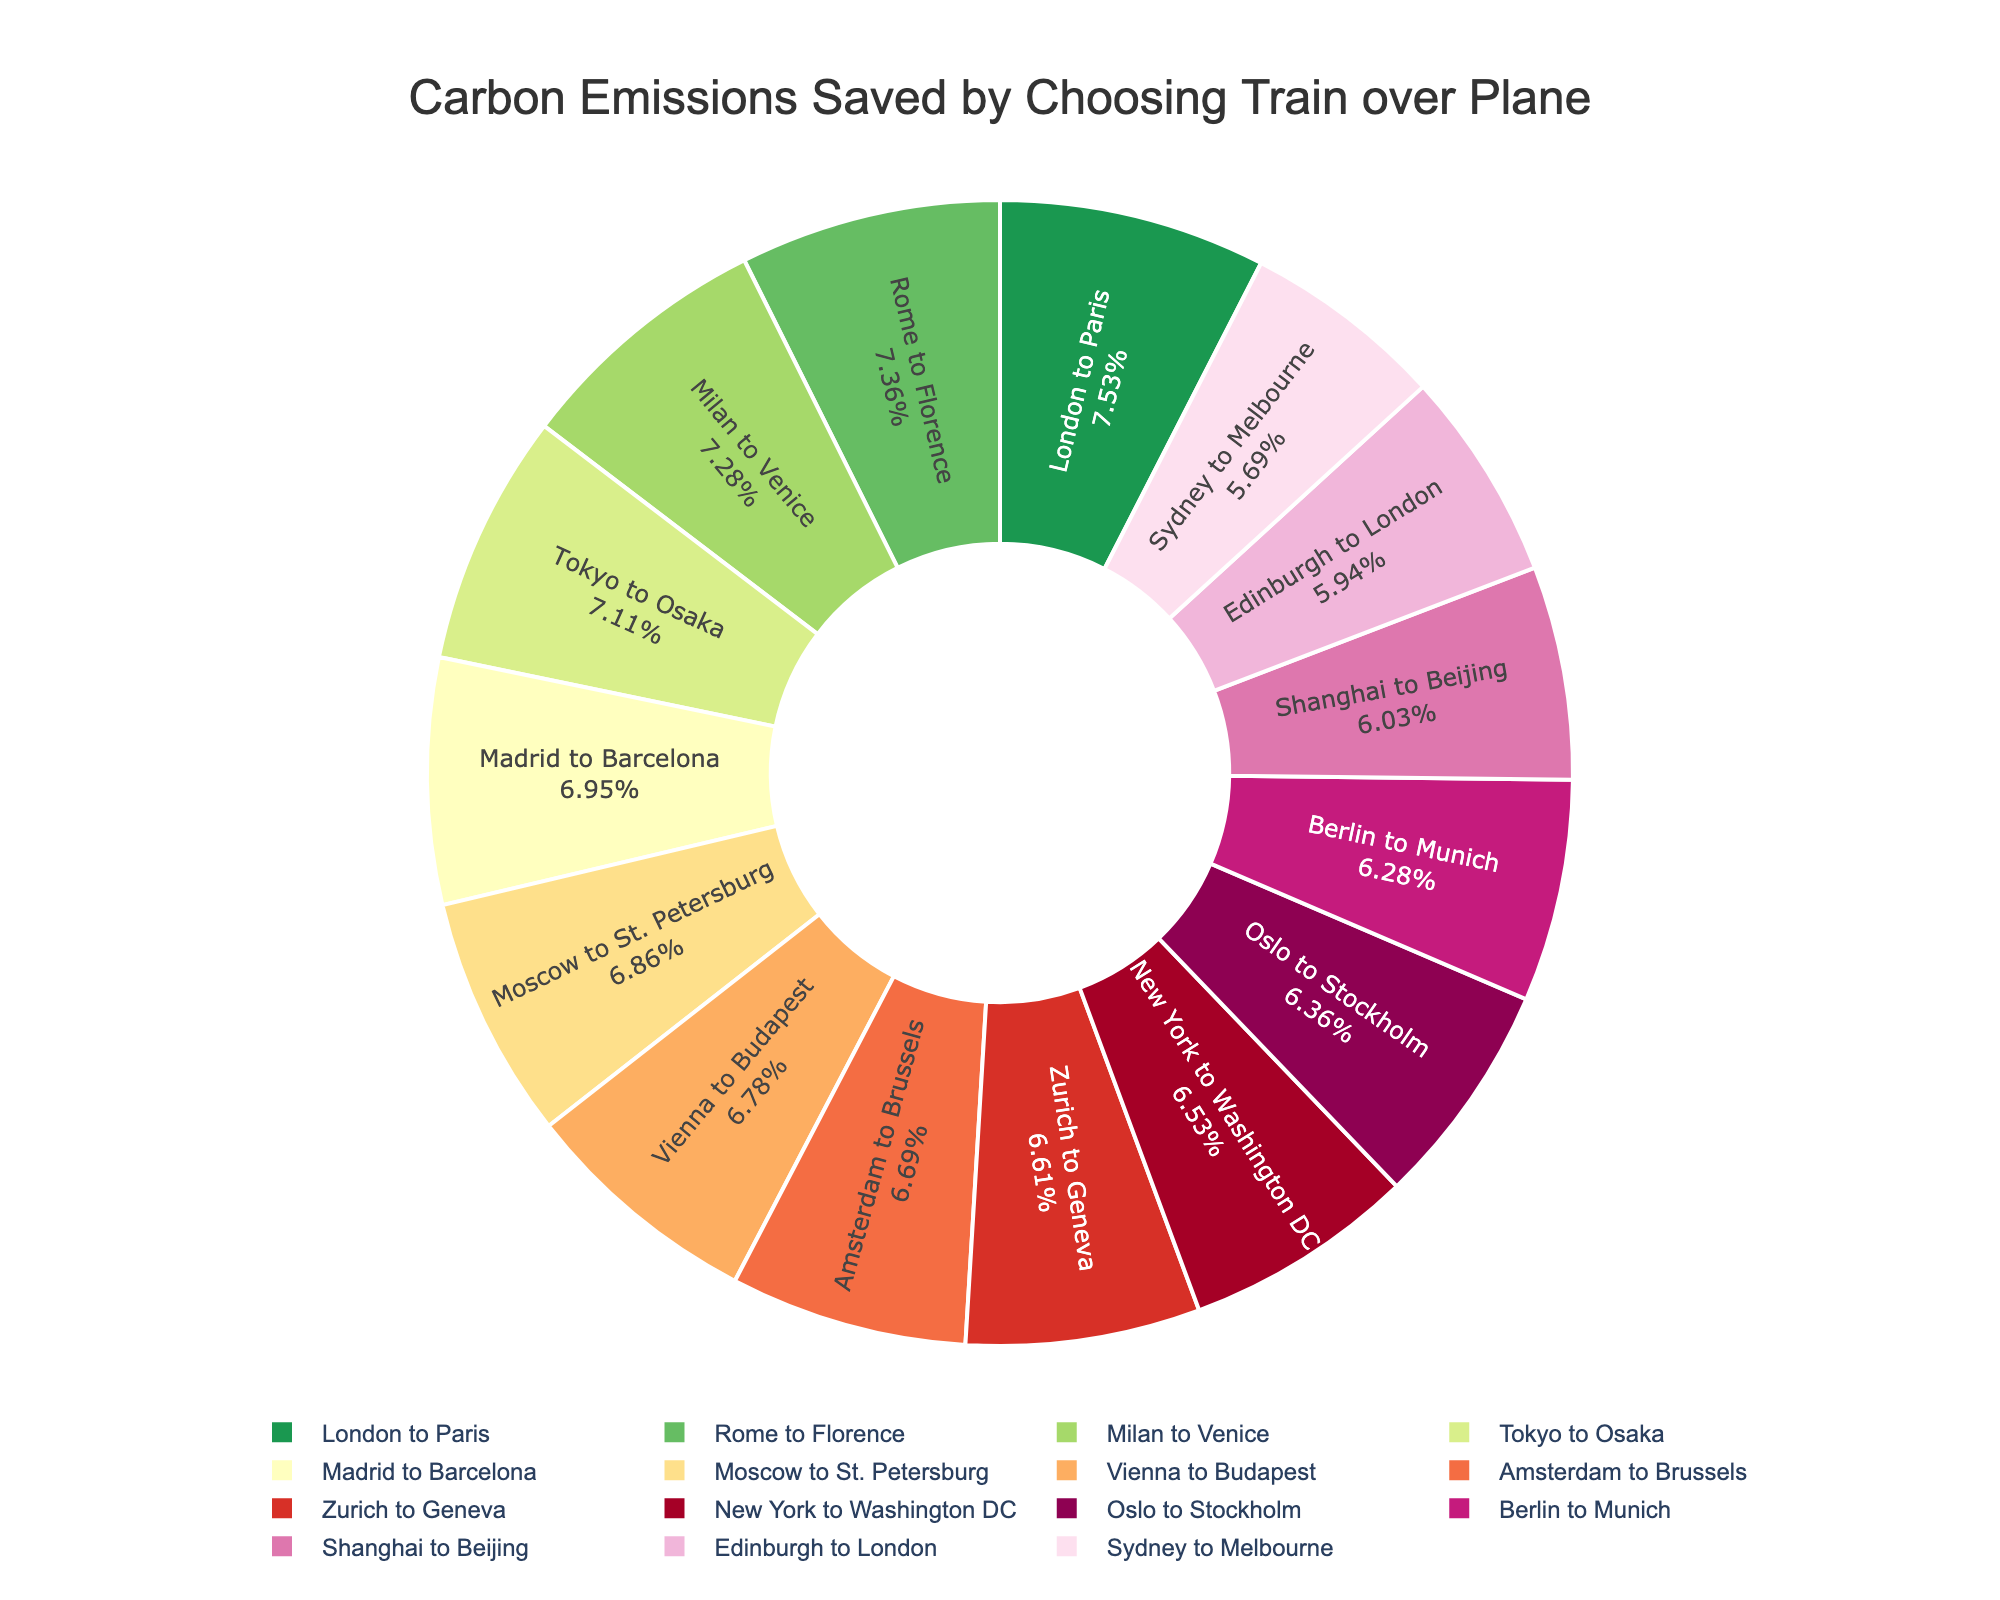Which route saves the highest percentage of carbon emissions by choosing train over plane? The highest percentage is the largest segment in the pie chart.
Answer: London to Paris How much carbon emissions are saved for the Rome to Florence route? Look at the Rome to Florence segment in the pie chart and find the percentage value.
Answer: 88% Which two routes have a carbon emissions saving percentage greater than 85%? Identify the segments with percentages higher than 85% in the pie chart and list the routes.
Answer: London to Paris, Tokyo to Osaka How many routes have a carbon emissions saving percentage below 80%? Count the segments with percentages less than 80% in the pie chart.
Answer: 4 Which route between Madrid to Barcelona and Zurich to Geneva saves more carbon emissions? Compare the percentages of the segments for these two routes in the pie chart.
Answer: Madrid to Barcelona What is the difference in carbon emissions saved between Amsterdam to Brussels and Sydney to Melbourne? Find the percentages for both routes and subtract the smaller from the larger.
Answer: 12% Which route has the lowest percentage of carbon emissions saved? The smallest segment in the pie chart represents the lowest percentage.
Answer: Sydney to Melbourne List the top three routes in terms of carbon emissions saved. Identify the three largest segments in the pie chart and list the corresponding routes.
Answer: London to Paris, Rome to Florence, Milan to Venice What is the combined carbon emissions saved percentage for Berlin to Munich and Oslo to Stockholm routes? Add the percentages of the Berlin to Munich and Oslo to Stockholm segments.
Answer: 75% + 76% = 151% Which color represents the Vienna to Budapest route? Find the Vienna to Budapest segment in the pie chart and note its color.
Answer: Green 